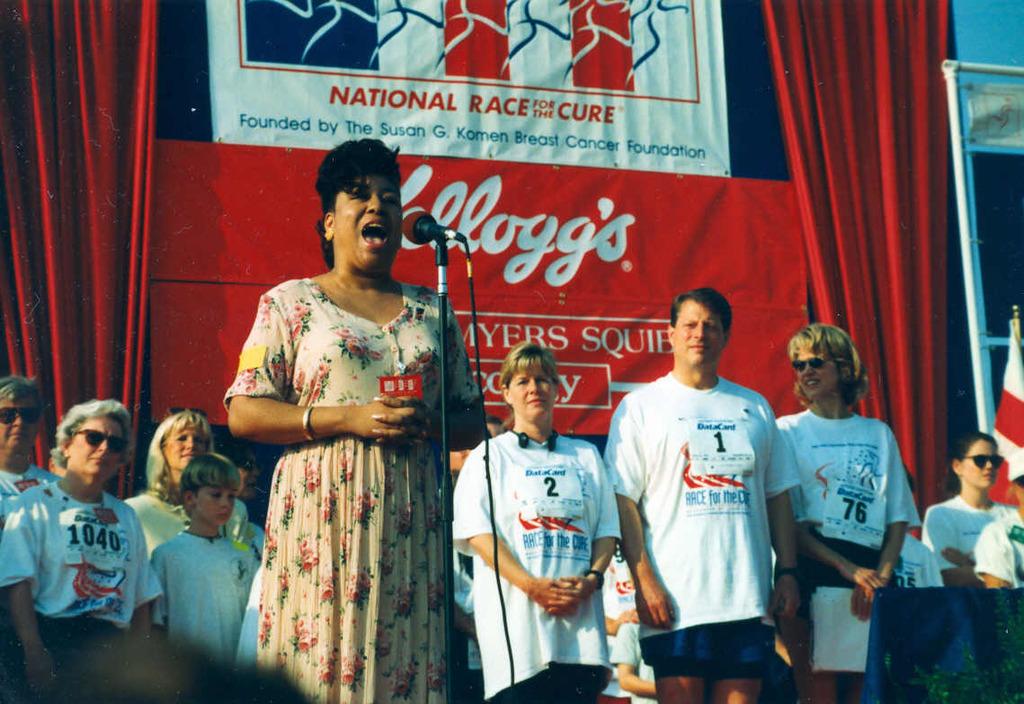What are they racing for?
Provide a short and direct response. The cure. Who is the sponsor?
Make the answer very short. Kelloggs. 